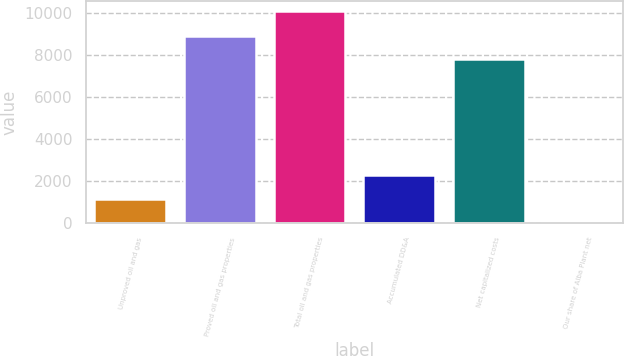Convert chart to OTSL. <chart><loc_0><loc_0><loc_500><loc_500><bar_chart><fcel>Unproved oil and gas<fcel>Proved oil and gas properties<fcel>Total oil and gas properties<fcel>Accumulated DD&A<fcel>Net capitalized costs<fcel>Our share of Alba Plant net<nl><fcel>1165<fcel>8903<fcel>10068<fcel>2281<fcel>7787<fcel>117<nl></chart> 